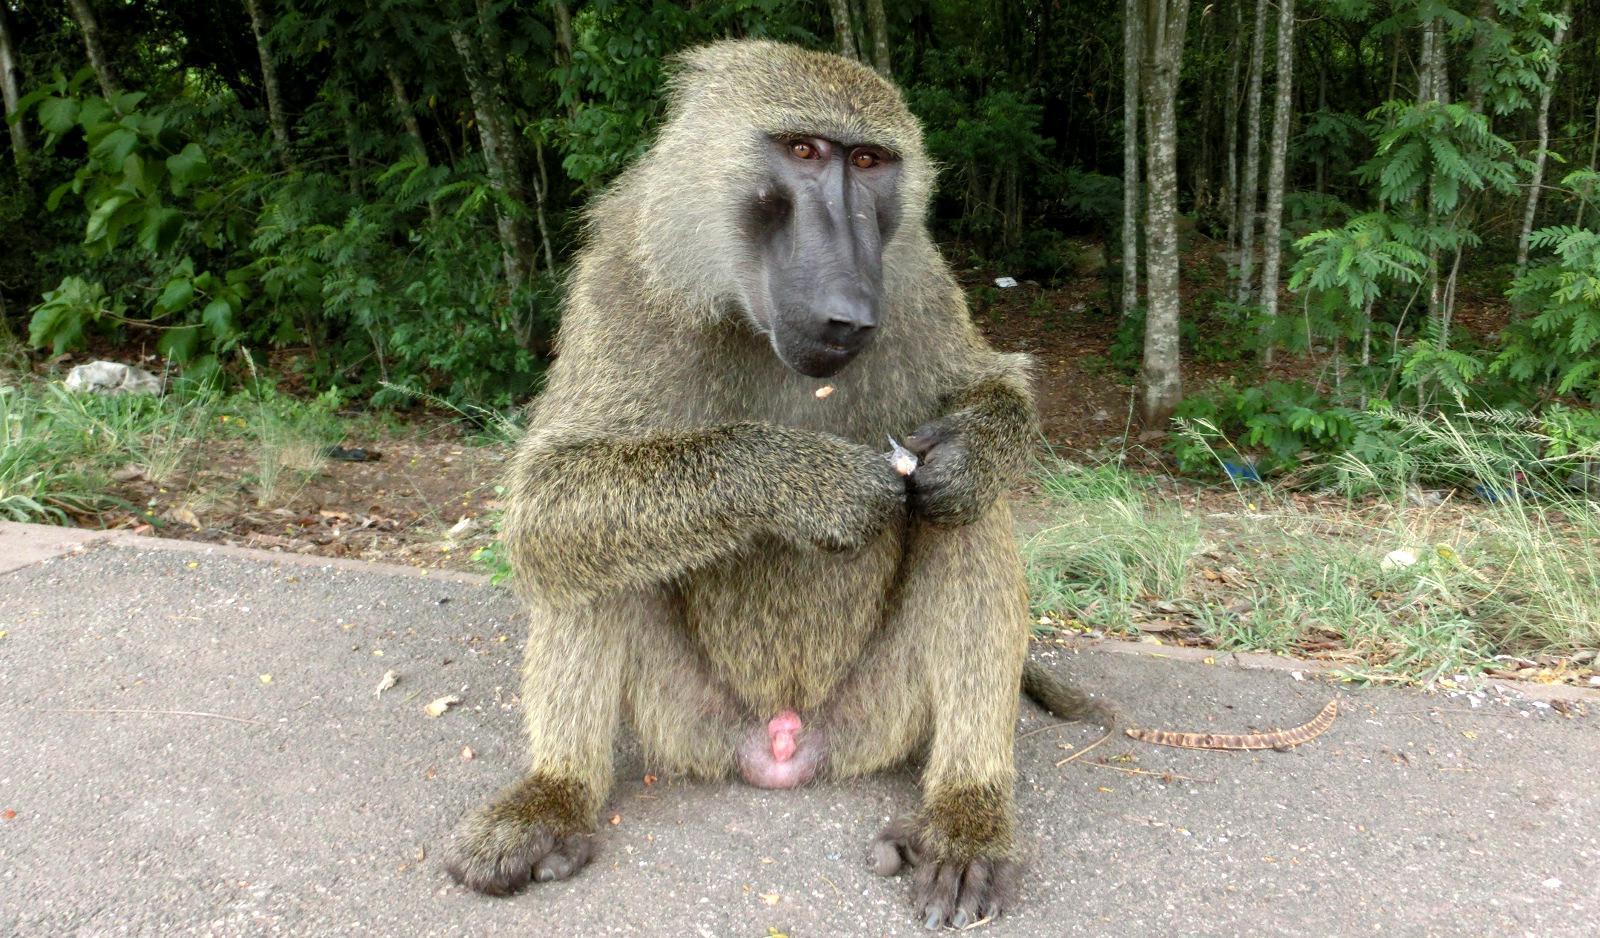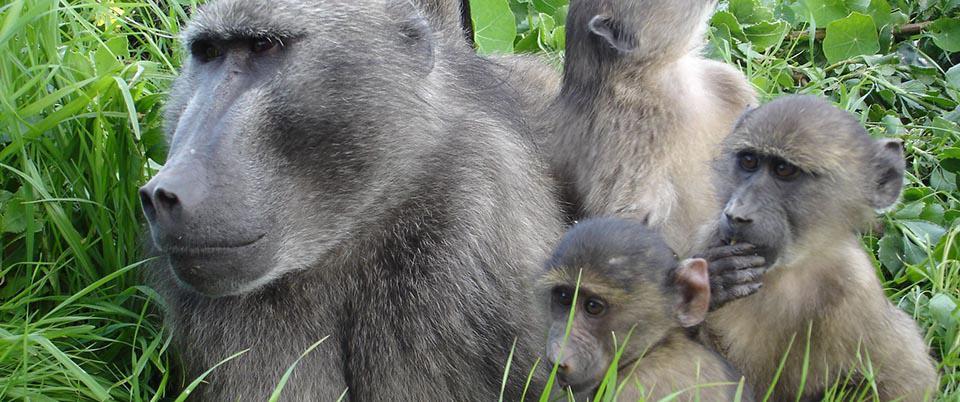The first image is the image on the left, the second image is the image on the right. Evaluate the accuracy of this statement regarding the images: "An image includes a leftward-moving adult baboon walking on all fours, and each image includes one baboon on all fours.". Is it true? Answer yes or no. No. 